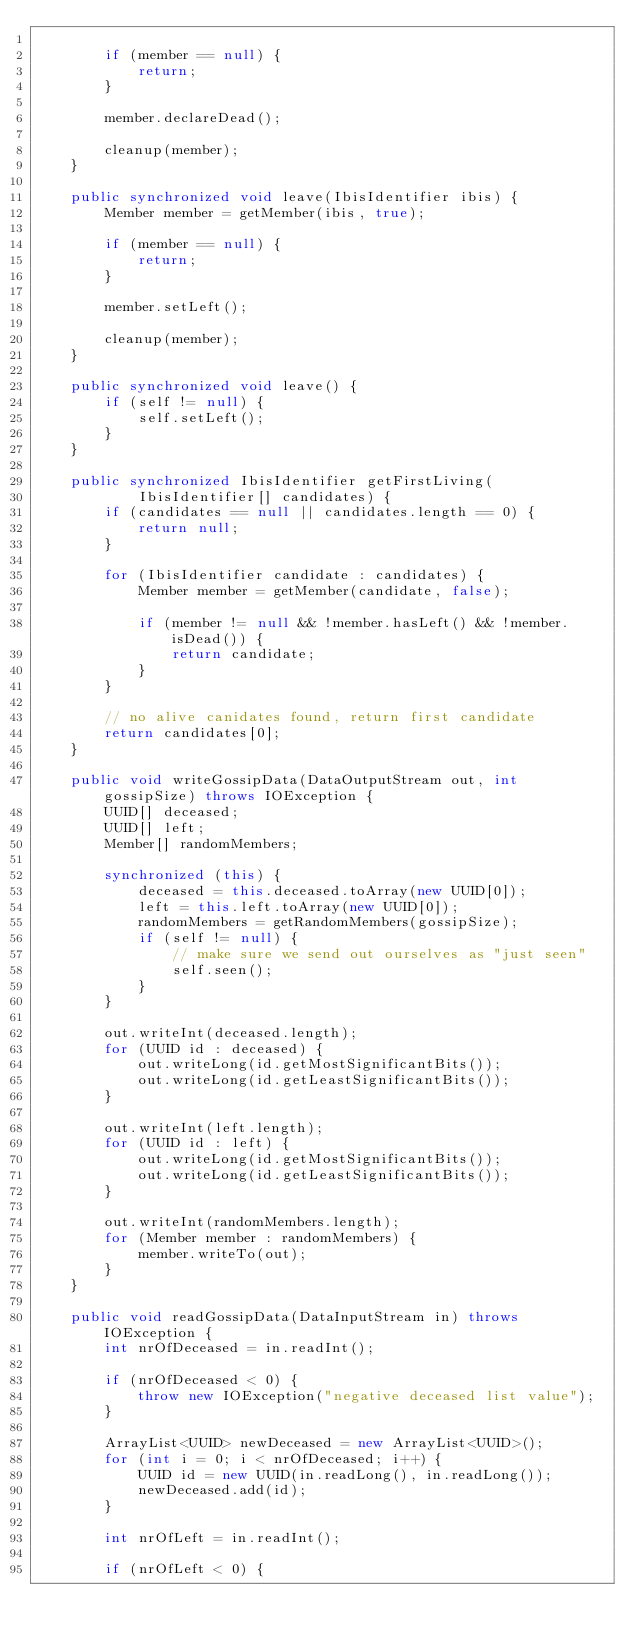<code> <loc_0><loc_0><loc_500><loc_500><_Java_>
        if (member == null) {
            return;
        }

        member.declareDead();

        cleanup(member);
    }

    public synchronized void leave(IbisIdentifier ibis) {
        Member member = getMember(ibis, true);

        if (member == null) {
            return;
        }

        member.setLeft();

        cleanup(member);
    }

    public synchronized void leave() {
        if (self != null) {
            self.setLeft();
        }
    }

    public synchronized IbisIdentifier getFirstLiving(
            IbisIdentifier[] candidates) {
        if (candidates == null || candidates.length == 0) {
            return null;
        }

        for (IbisIdentifier candidate : candidates) {
            Member member = getMember(candidate, false);

            if (member != null && !member.hasLeft() && !member.isDead()) {
                return candidate;
            }
        }

        // no alive canidates found, return first candidate
        return candidates[0];
    }

    public void writeGossipData(DataOutputStream out, int gossipSize) throws IOException {
        UUID[] deceased;
        UUID[] left;
        Member[] randomMembers;

        synchronized (this) {
            deceased = this.deceased.toArray(new UUID[0]);
            left = this.left.toArray(new UUID[0]);
            randomMembers = getRandomMembers(gossipSize);
            if (self != null) {
                // make sure we send out ourselves as "just seen"
                self.seen();
            }
        }

        out.writeInt(deceased.length);
        for (UUID id : deceased) {
            out.writeLong(id.getMostSignificantBits());
            out.writeLong(id.getLeastSignificantBits());
        }

        out.writeInt(left.length);
        for (UUID id : left) {
            out.writeLong(id.getMostSignificantBits());
            out.writeLong(id.getLeastSignificantBits());
        }

        out.writeInt(randomMembers.length);
        for (Member member : randomMembers) {
            member.writeTo(out);
        }
    }

    public void readGossipData(DataInputStream in) throws IOException {
        int nrOfDeceased = in.readInt();

        if (nrOfDeceased < 0) {
            throw new IOException("negative deceased list value");
        }

        ArrayList<UUID> newDeceased = new ArrayList<UUID>();
        for (int i = 0; i < nrOfDeceased; i++) {
            UUID id = new UUID(in.readLong(), in.readLong());
            newDeceased.add(id);
        }

        int nrOfLeft = in.readInt();

        if (nrOfLeft < 0) {</code> 